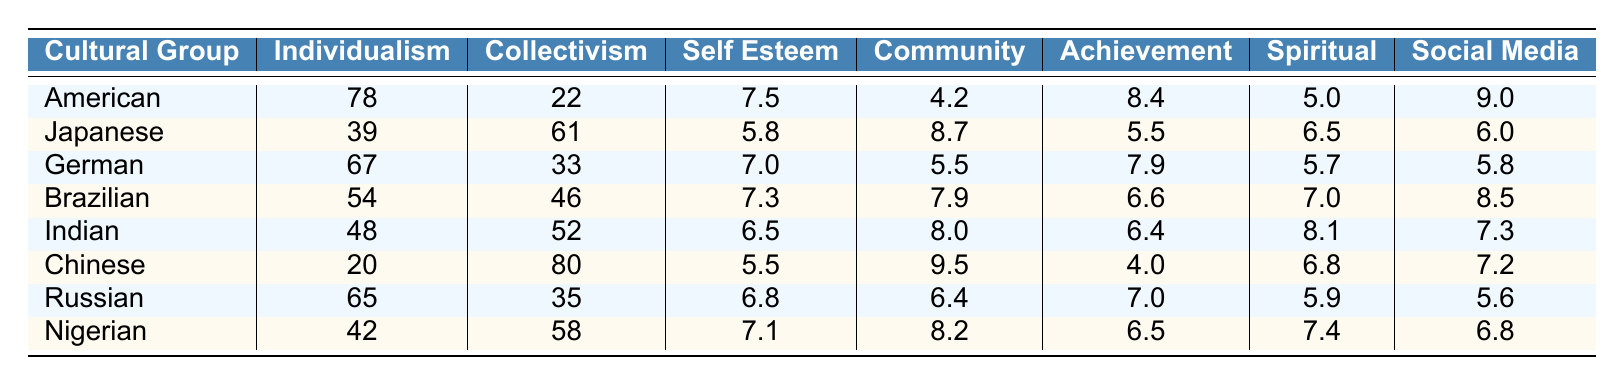What is the Individualism Score for the American cultural group? The table lists the Individualism Score for the American cultural group as 78.
Answer: 78 Which cultural group has the highest Self Esteem score? By examining the Self Esteem values, the American group has the highest score of 7.5, higher than any other group.
Answer: American What is the average Collectivism Score across all cultural groups? The Collectivism Scores are 22, 61, 33, 46, 52, 80, 35, and 58. Adding these gives  22 + 61 + 33 + 46 + 52 + 80 + 35 + 58 =  392. Since there are 8 groups, the average is 392 / 8 = 49.
Answer: 49 Is the Social Media Influence score for the Chinese cultural group higher than that for the Japanese group? The Social Media Influence score for the Chinese group is 7.2, while for the Japanese group it is 6.0. Since 7.2 is greater than 6.0, the statement is true.
Answer: Yes What is the difference in Spiritual Self Concept scores between the Brazilian and Chinese cultural groups? The Spiritual Self Concept for Brazilians is 7.0 and for Chinese is 6.8. The difference is calculated as 7.0 - 6.8 = 0.2.
Answer: 0.2 Which cultural group has the lowest Importance of Community score? The table shows the Importance of Community scores, where the American group has the lowest score of 4.2.
Answer: American If you sum the Personal Achievement Orientation scores for all groups, what is the total? The Personal Achievement Orientation scores are 8.4, 5.5, 7.9, 6.6, 6.4, 4.0, 7.0, and 6.5. Adding these gives 8.4 + 5.5 + 7.9 + 6.6 + 6.4 + 4.0 + 7.0 + 6.5 = 52.3.
Answer: 52.3 Are Nigerian cultural group members more focused on community compared to the Russian cultural group members? The Importance of Community score for Nigerians is 8.2, while for Russians it is 6.4. Since 8.2 is greater than 6.4, Nigerians are indeed more focused on community.
Answer: Yes Which cultural group has a greater emphasis on Personal Achievement Orientation: German or Indian? The scores indicate that the Germans have a Personal Achievement Orientation of 7.9, while the Indians score 6.4. Since 7.9 is greater than 6.4, Germans place a greater emphasis.
Answer: German What is the median Self Esteem score among the cultural groups? The Self Esteem scores are 7.5, 5.8, 7.0, 7.3, 6.5, 5.5, 6.8, and 7.1. Arranging these scores in order gives (5.5, 5.8, 6.5, 6.8, 7.0, 7.1, 7.3, 7.5). With eight scores, the median is the average of the 4th and 5th, which is (6.8 + 7.0)/2 = 6.9.
Answer: 6.9 